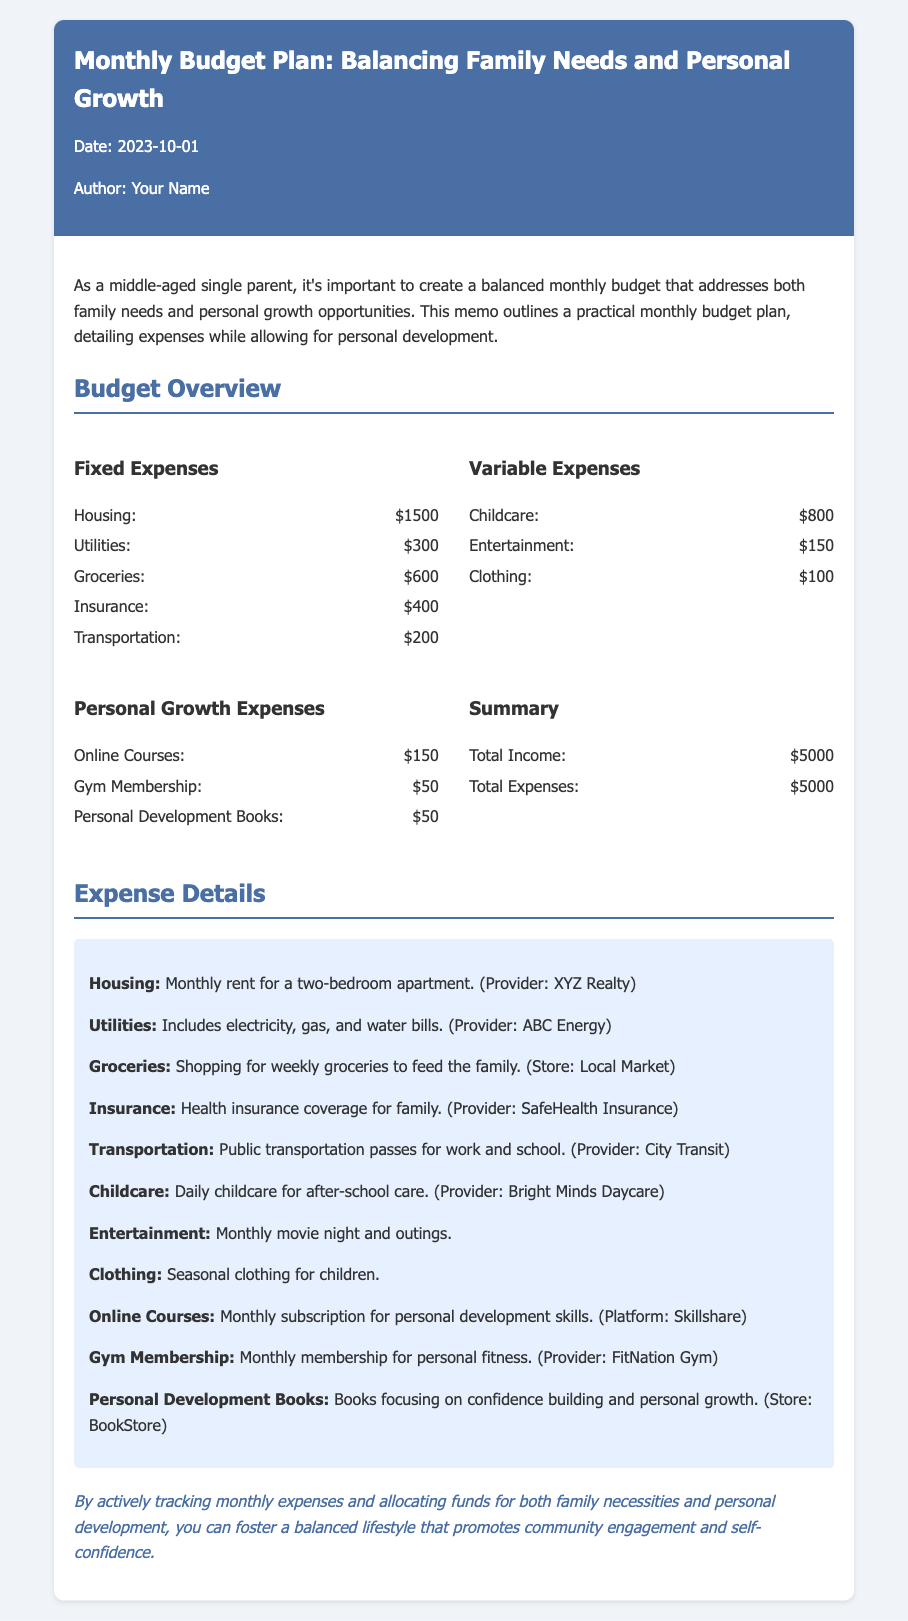What is the total income? The total income is listed in the summary section of the budget overview, which states $5000 as the total income for the month.
Answer: $5000 What is the amount allocated for groceries? The amount allocated for groceries is indicated in the fixed expenses section, showing $600 under groceries.
Answer: $600 How much is spent on online courses? The spending on online courses is specified in the personal growth expenses section, where it states $150 for online courses.
Answer: $150 What type of documents does this memo address? This memo addresses a budget plan, specifically focusing on balancing family needs and personal growth expenses.
Answer: Budget plan Which expense category has the highest expenditure? By comparing the fixed and variable expenses categories, childcare is the highest, with $800 allocated for it.
Answer: Childcare How much is spent on personal development books? In the personal growth expenses section, $50 is noted as the amount spent on personal development books.
Answer: $50 What is included in the utilities expense? The utilities expense includes electricity, gas, and water bills as stated in the expense details.
Answer: Electricity, gas, water What is the purpose of this memo? The purpose of the memo is to outline a practical monthly budget plan that addresses family needs and personal growth opportunities.
Answer: Outline budget plan 